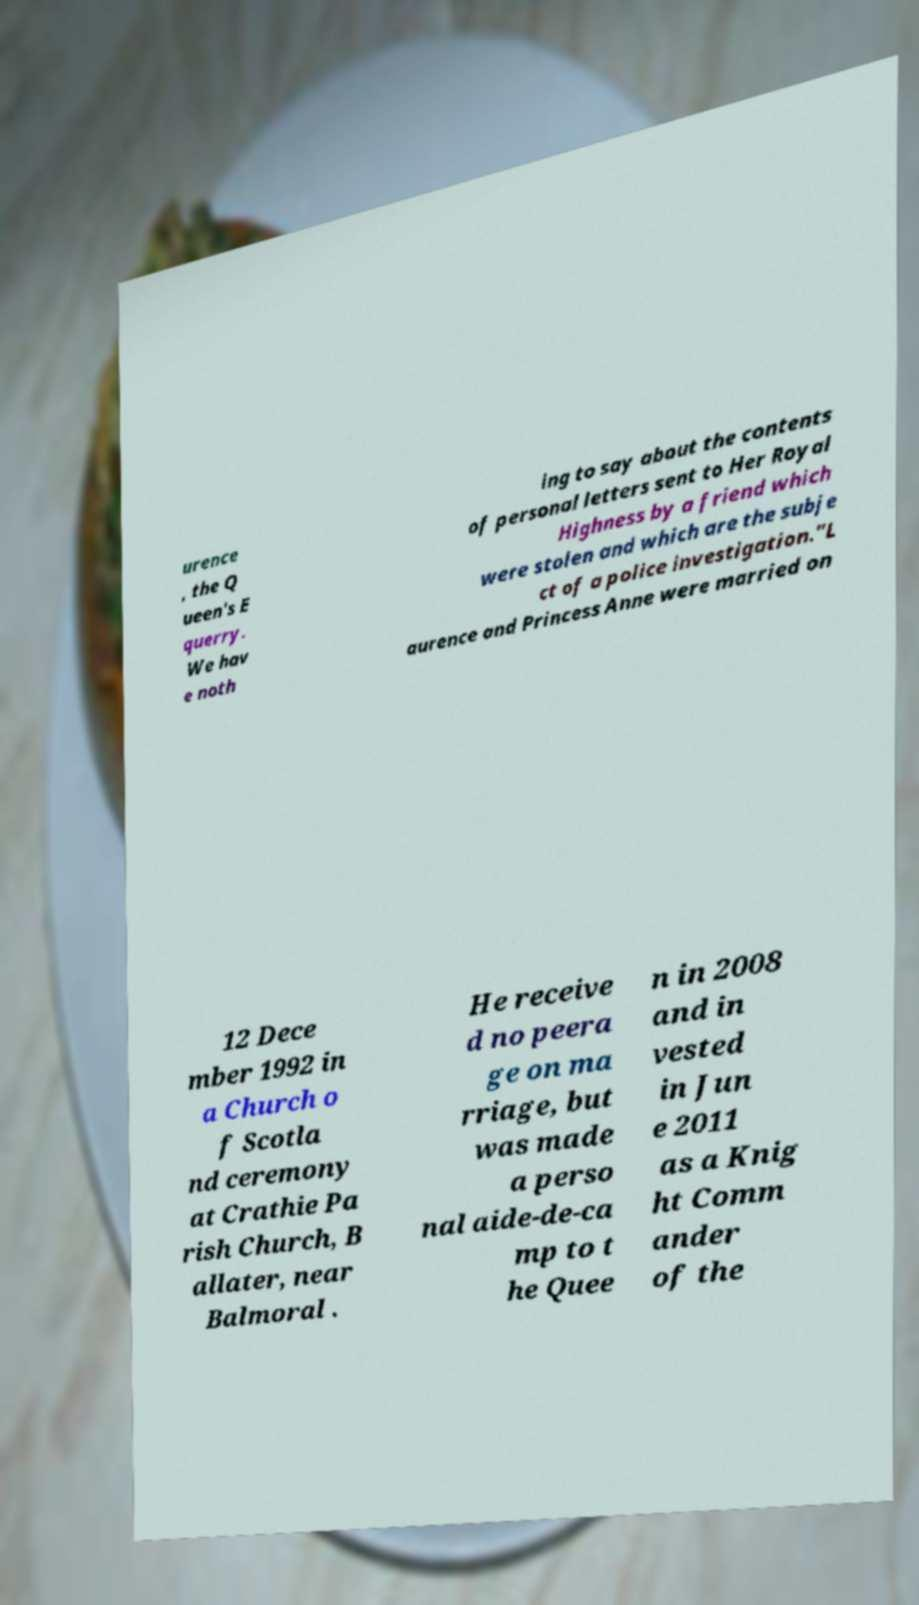I need the written content from this picture converted into text. Can you do that? urence , the Q ueen's E querry. We hav e noth ing to say about the contents of personal letters sent to Her Royal Highness by a friend which were stolen and which are the subje ct of a police investigation."L aurence and Princess Anne were married on 12 Dece mber 1992 in a Church o f Scotla nd ceremony at Crathie Pa rish Church, B allater, near Balmoral . He receive d no peera ge on ma rriage, but was made a perso nal aide-de-ca mp to t he Quee n in 2008 and in vested in Jun e 2011 as a Knig ht Comm ander of the 